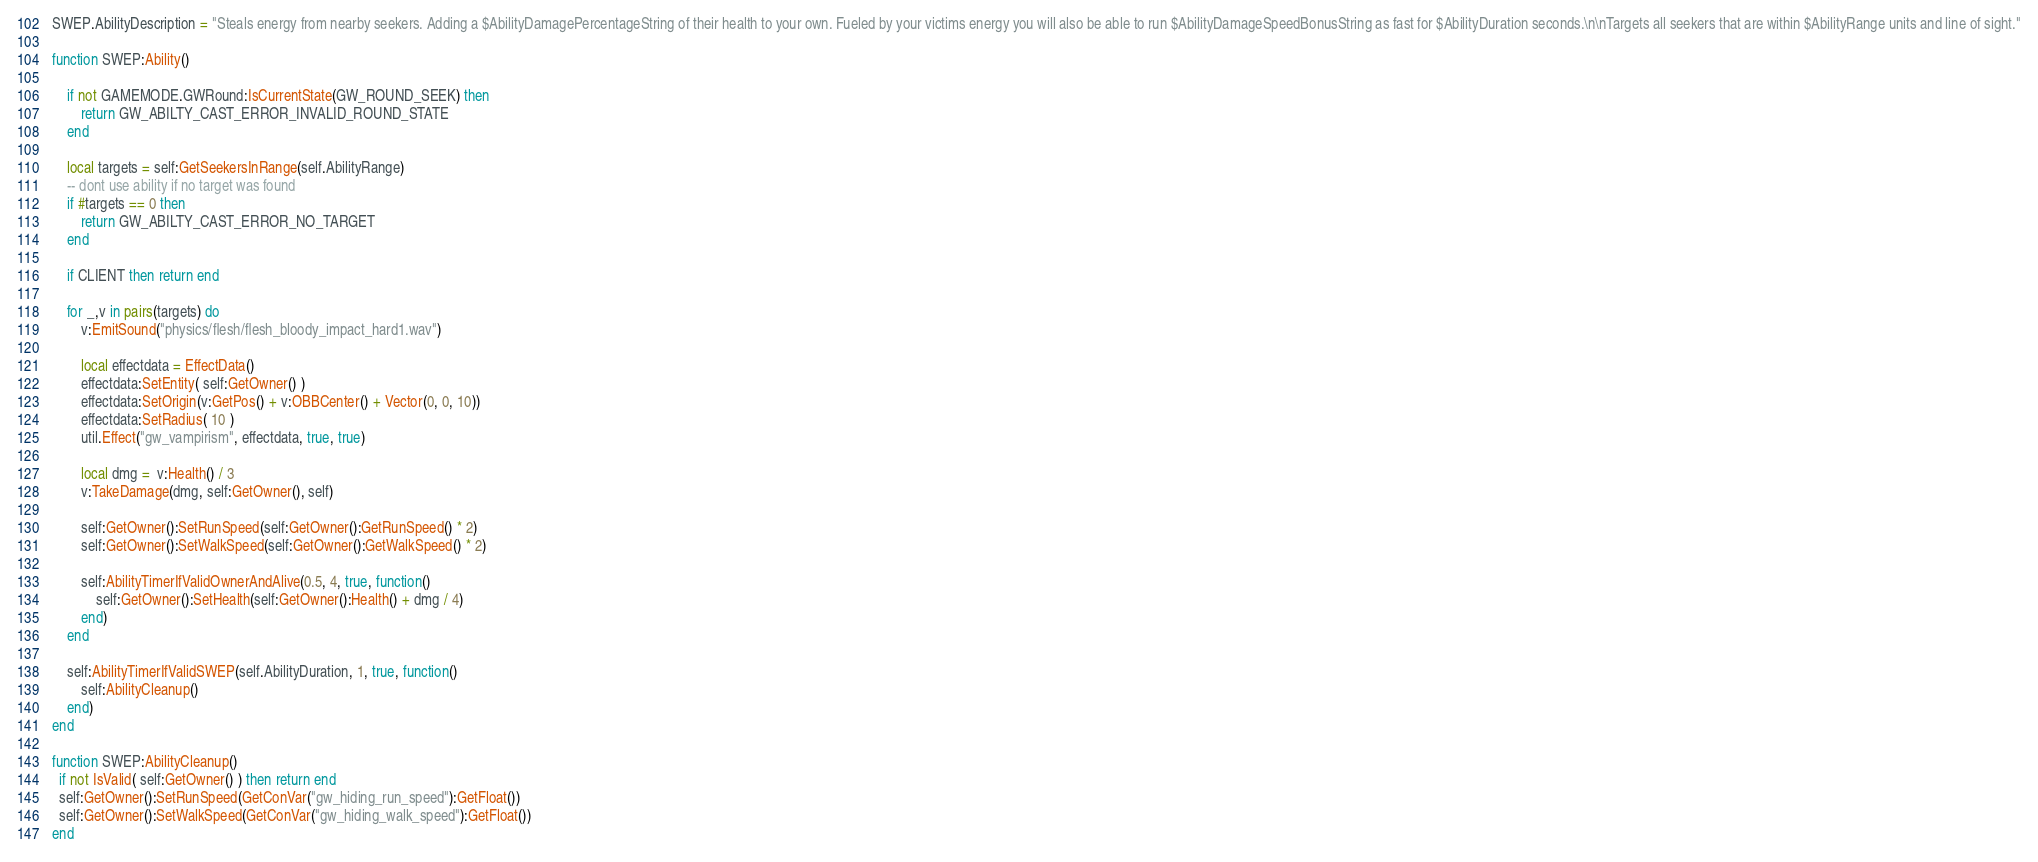Convert code to text. <code><loc_0><loc_0><loc_500><loc_500><_Lua_>
SWEP.AbilityDescription = "Steals energy from nearby seekers. Adding a $AbilityDamagePercentageString of their health to your own. Fueled by your victims energy you will also be able to run $AbilityDamageSpeedBonusString as fast for $AbilityDuration seconds.\n\nTargets all seekers that are within $AbilityRange units and line of sight."

function SWEP:Ability()

    if not GAMEMODE.GWRound:IsCurrentState(GW_ROUND_SEEK) then
        return GW_ABILTY_CAST_ERROR_INVALID_ROUND_STATE
    end

    local targets = self:GetSeekersInRange(self.AbilityRange)
    -- dont use ability if no target was found
    if #targets == 0 then
        return GW_ABILTY_CAST_ERROR_NO_TARGET
    end

    if CLIENT then return end

    for _,v in pairs(targets) do    
        v:EmitSound("physics/flesh/flesh_bloody_impact_hard1.wav")

        local effectdata = EffectData()
        effectdata:SetEntity( self:GetOwner() )
        effectdata:SetOrigin(v:GetPos() + v:OBBCenter() + Vector(0, 0, 10))
        effectdata:SetRadius( 10 )
        util.Effect("gw_vampirism", effectdata, true, true)

        local dmg =  v:Health() / 3
        v:TakeDamage(dmg, self:GetOwner(), self)

        self:GetOwner():SetRunSpeed(self:GetOwner():GetRunSpeed() * 2)
        self:GetOwner():SetWalkSpeed(self:GetOwner():GetWalkSpeed() * 2)

        self:AbilityTimerIfValidOwnerAndAlive(0.5, 4, true, function()
            self:GetOwner():SetHealth(self:GetOwner():Health() + dmg / 4)
        end)
    end

    self:AbilityTimerIfValidSWEP(self.AbilityDuration, 1, true, function()
        self:AbilityCleanup()
    end)
end

function SWEP:AbilityCleanup()
  if not IsValid( self:GetOwner() ) then return end
  self:GetOwner():SetRunSpeed(GetConVar("gw_hiding_run_speed"):GetFloat())
  self:GetOwner():SetWalkSpeed(GetConVar("gw_hiding_walk_speed"):GetFloat())
end
</code> 